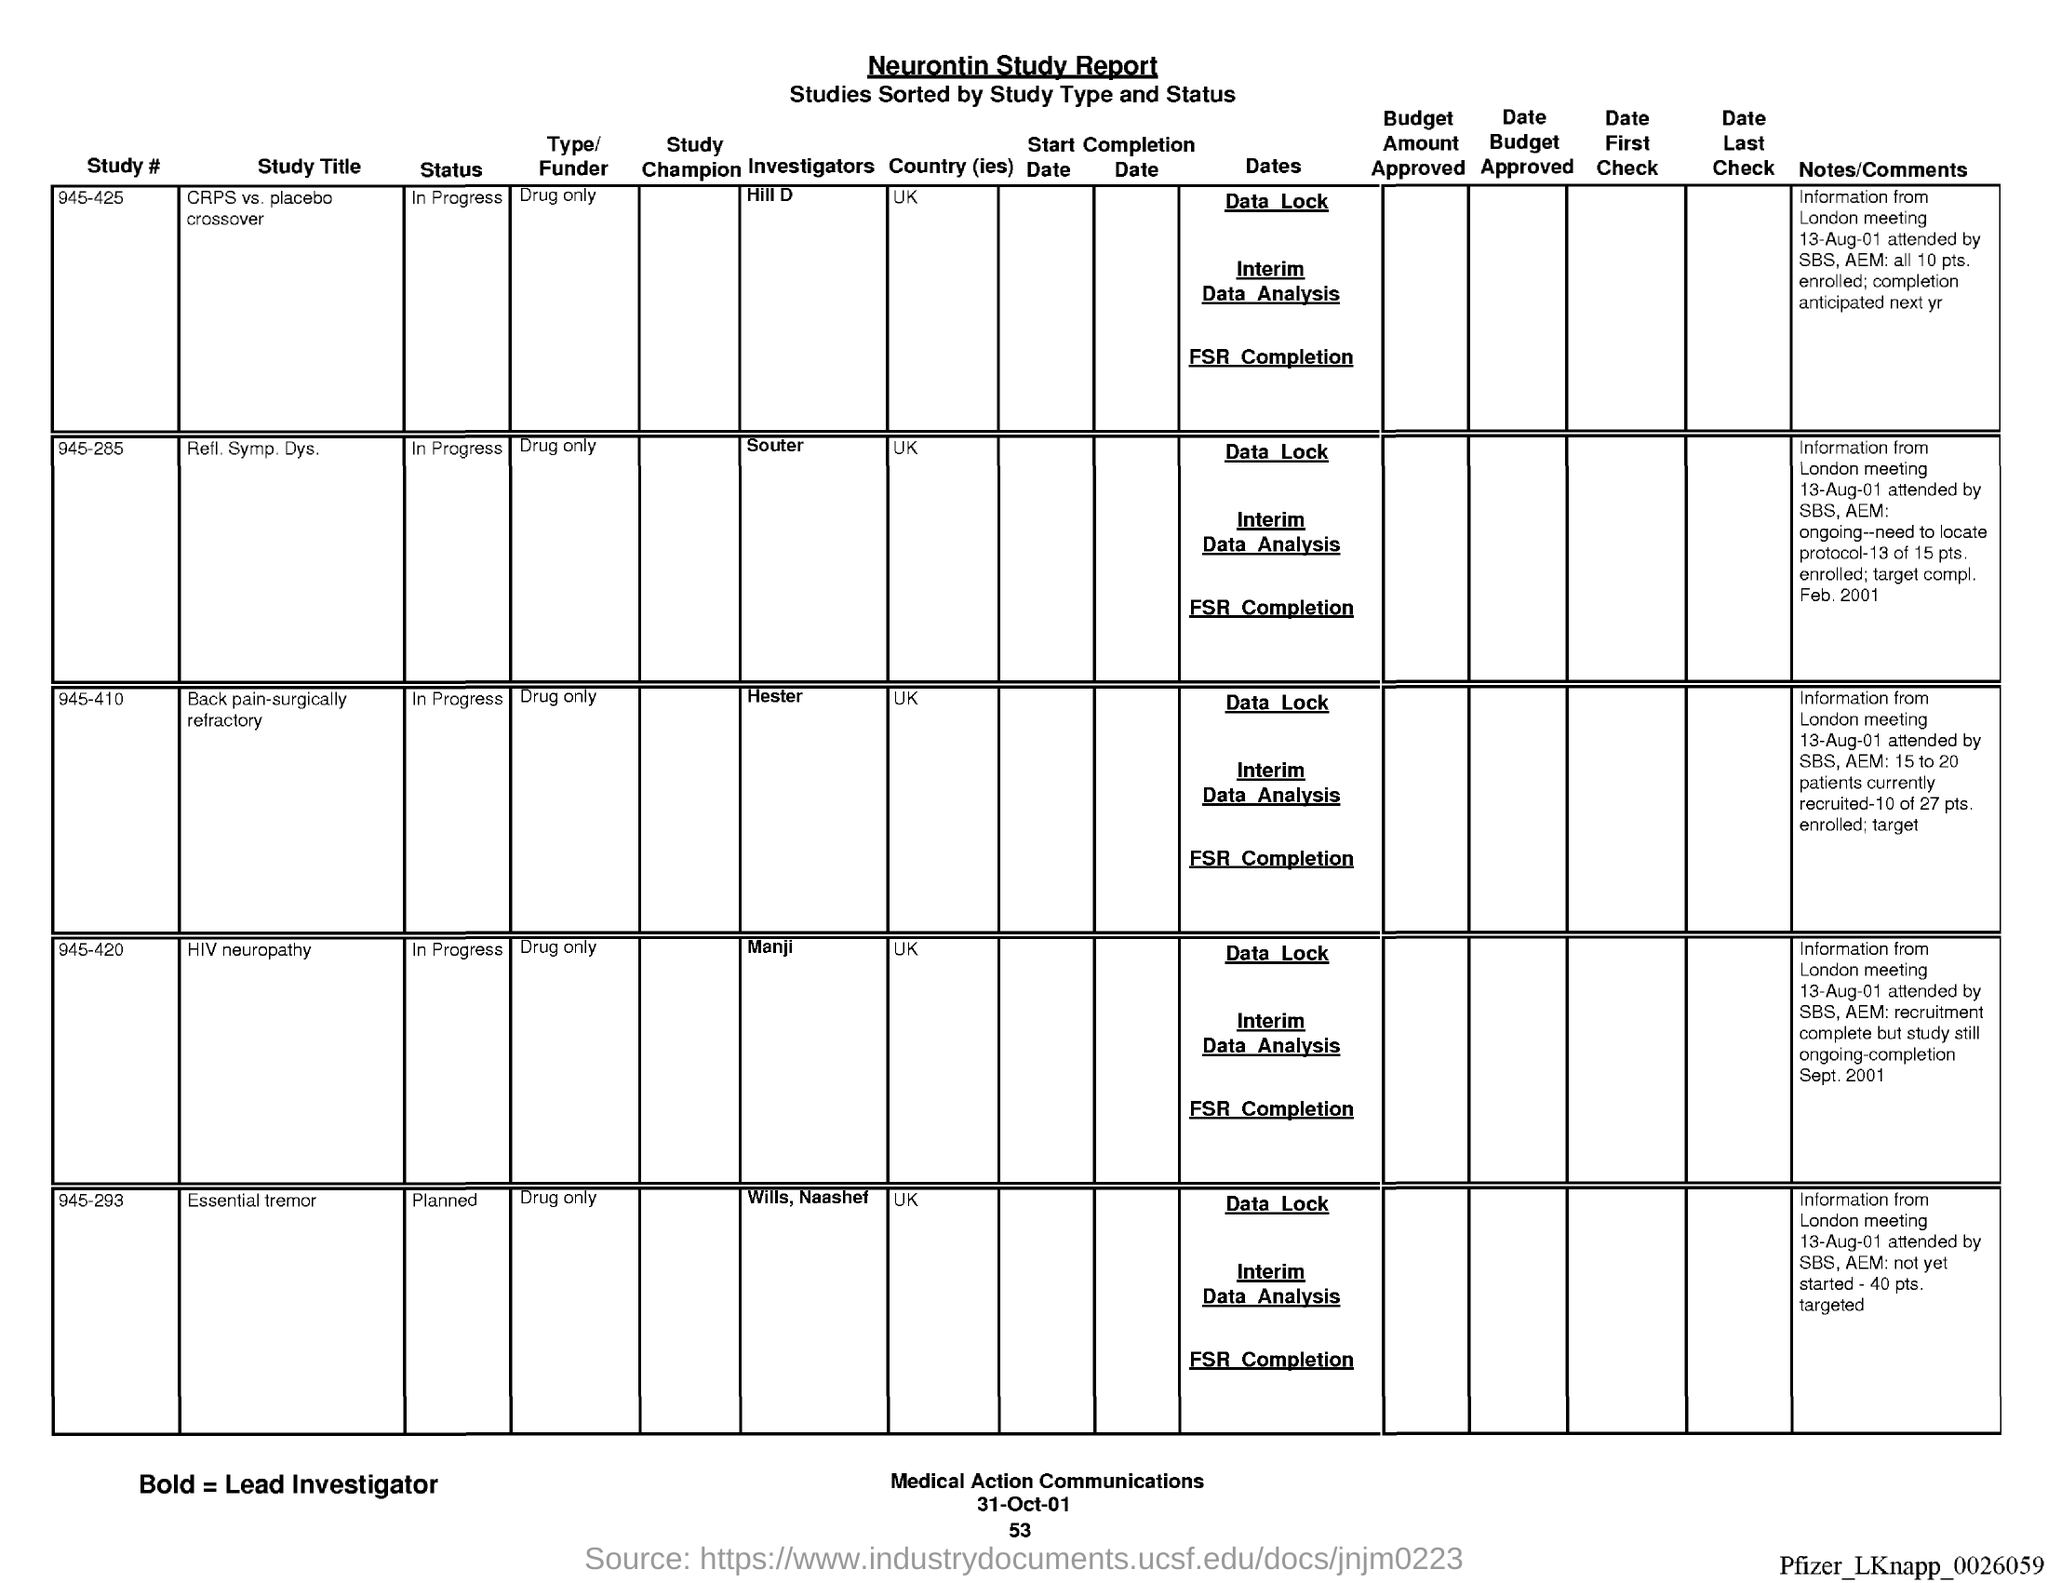What is the name of the report ?
Provide a short and direct response. Neurontin Study report. What is the page number below date?
Give a very brief answer. 53. 